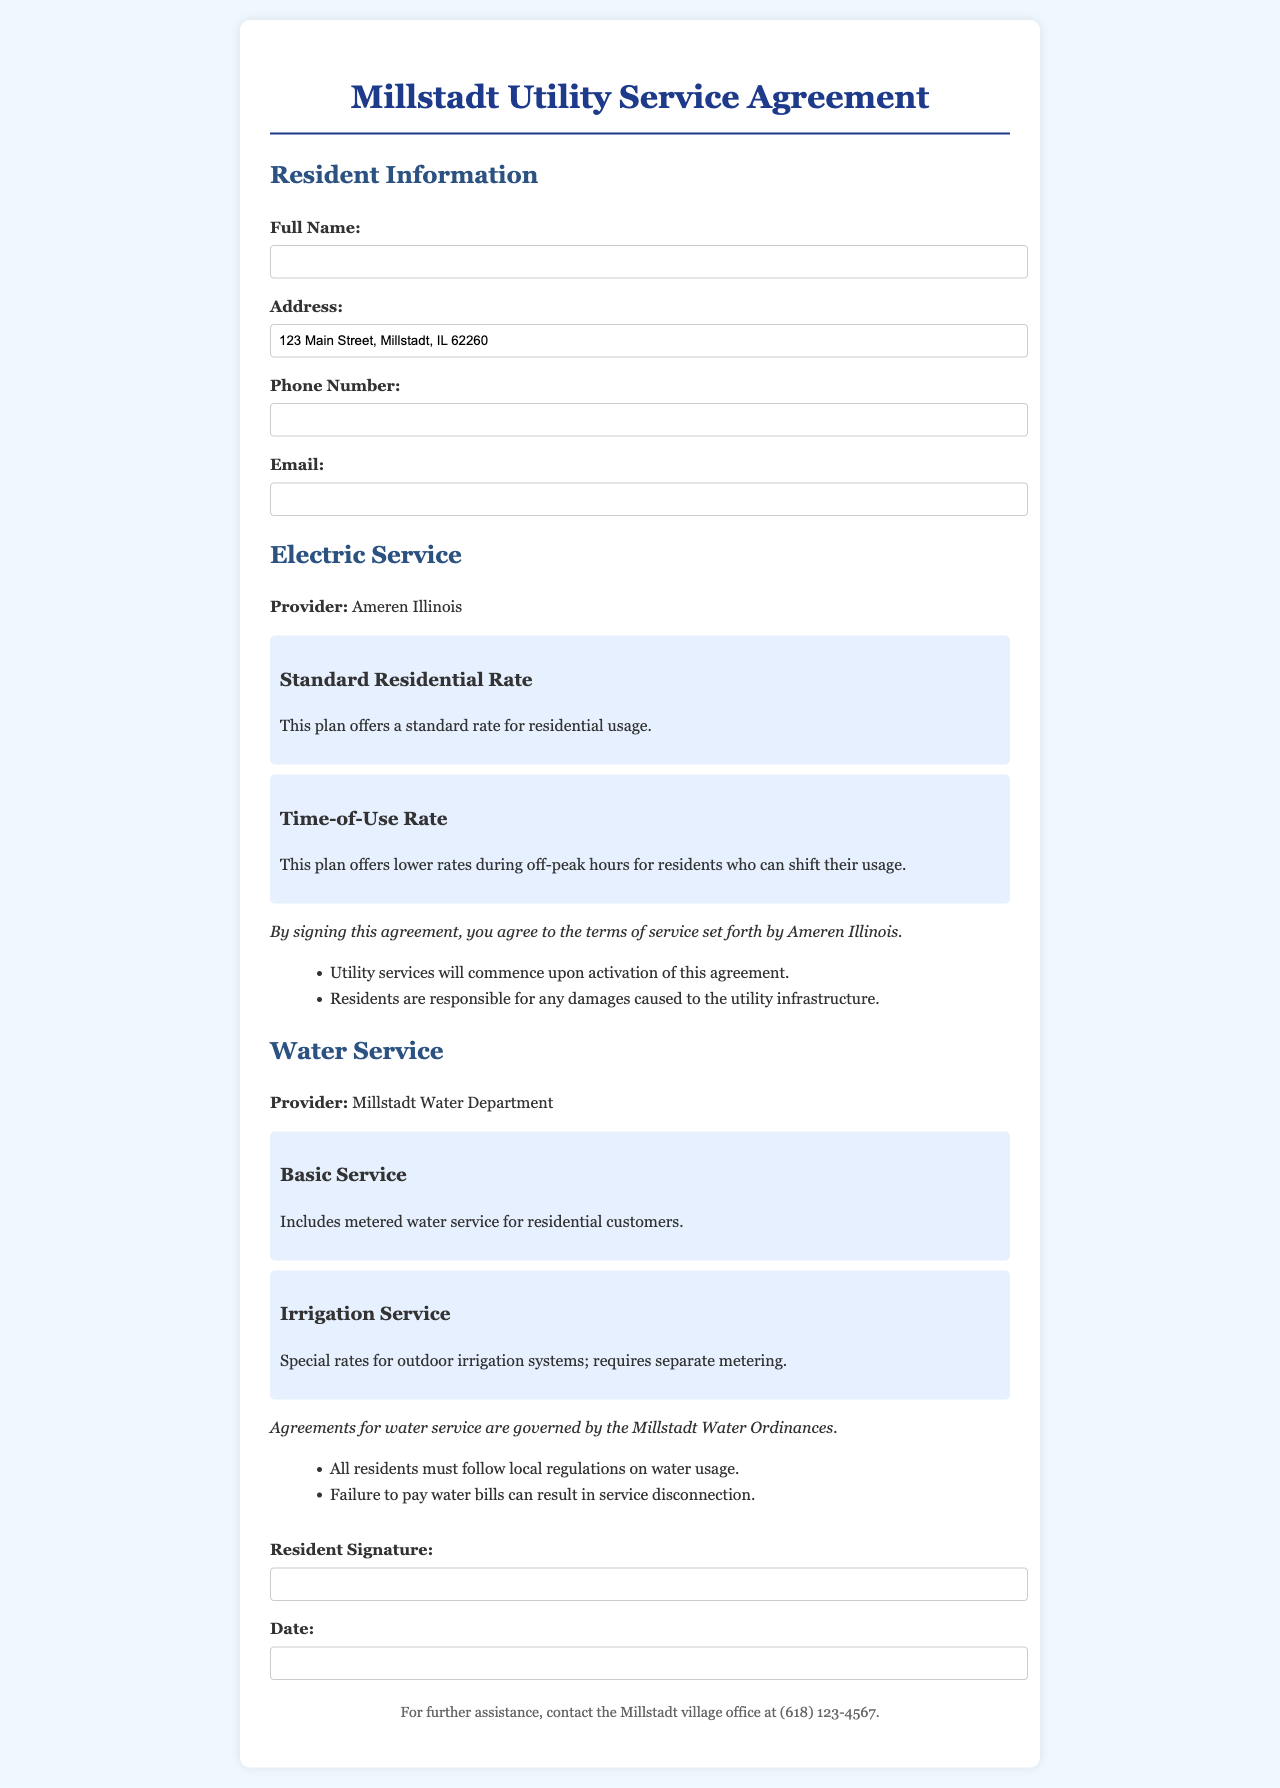What is the full name of the utility service provider for electricity? The document states that the electric service provider is Ameren Illinois.
Answer: Ameren Illinois What type of water service includes metered water service for residential customers? The document specifies that Basic Service includes metered water service for residential customers.
Answer: Basic Service What is the phone number to contact the Millstadt village office for assistance? The document provides the phone number for further assistance, which is (618) 123-4567.
Answer: (618) 123-4567 What must residents do to follow regulations on water usage? According to the document, all residents must follow local regulations on water usage as stated in the Water service section.
Answer: Follow local regulations on water usage What is required for the Irrigation Service option? The document indicates that Irrigation Service requires separate metering.
Answer: Separate metering What service offers lower rates during off-peak hours? The document mentions the Time-of-Use Rate plan which offers lower rates for shifting usage.
Answer: Time-of-Use Rate What should residents be responsible for according to the terms of service for electric service? The document outlines that residents are responsible for any damages caused to the utility infrastructure.
Answer: Damages to the utility infrastructure What type of signature is required from the resident? The document states a Resident Signature is required at the end of the agreement.
Answer: Resident Signature 